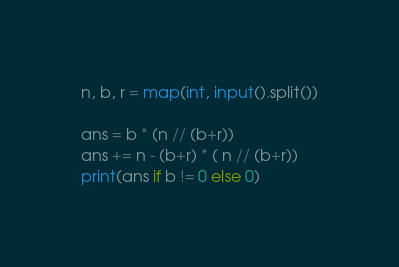<code> <loc_0><loc_0><loc_500><loc_500><_Python_>n, b, r = map(int, input().split())

ans = b * (n // (b+r))
ans += n - (b+r) * ( n // (b+r))
print(ans if b != 0 else 0)
</code> 